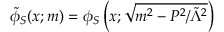<formula> <loc_0><loc_0><loc_500><loc_500>\tilde { \phi } _ { S } ( x ; m ) = \phi _ { S } \left ( x ; \sqrt { m ^ { 2 } - P ^ { 2 } / \tilde { \Lambda } ^ { 2 } } \right )</formula> 